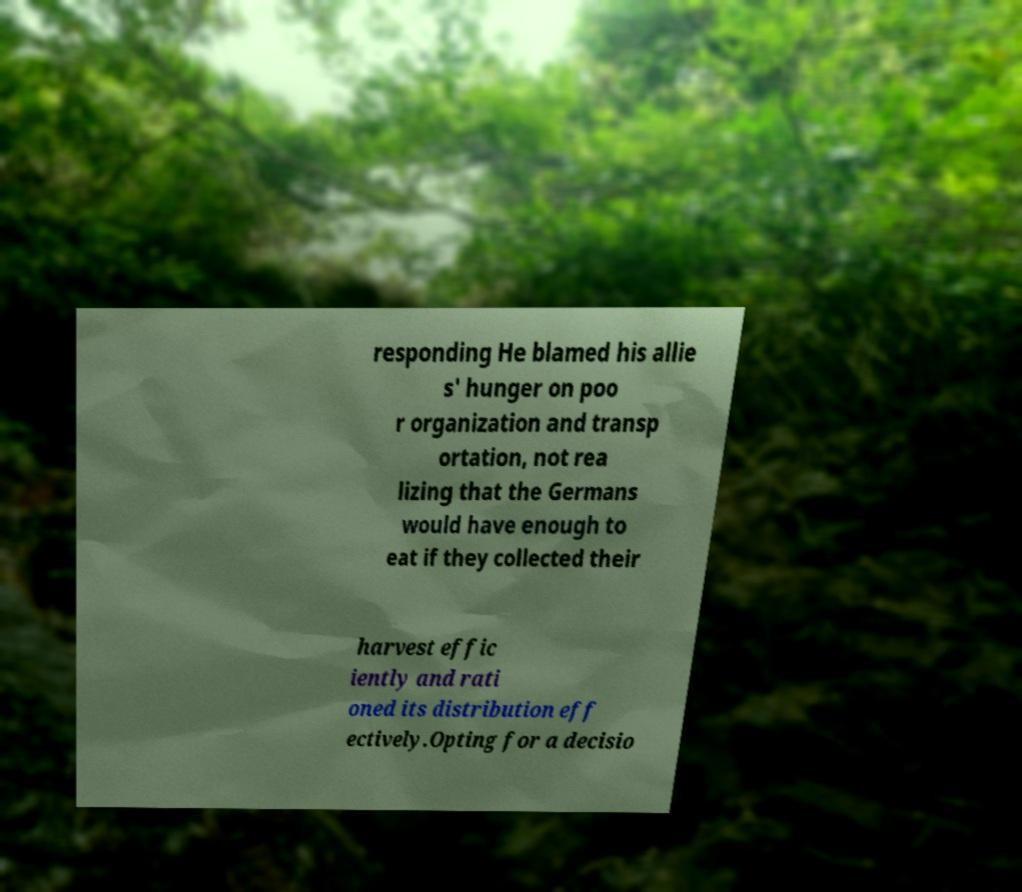Could you assist in decoding the text presented in this image and type it out clearly? responding He blamed his allie s' hunger on poo r organization and transp ortation, not rea lizing that the Germans would have enough to eat if they collected their harvest effic iently and rati oned its distribution eff ectively.Opting for a decisio 